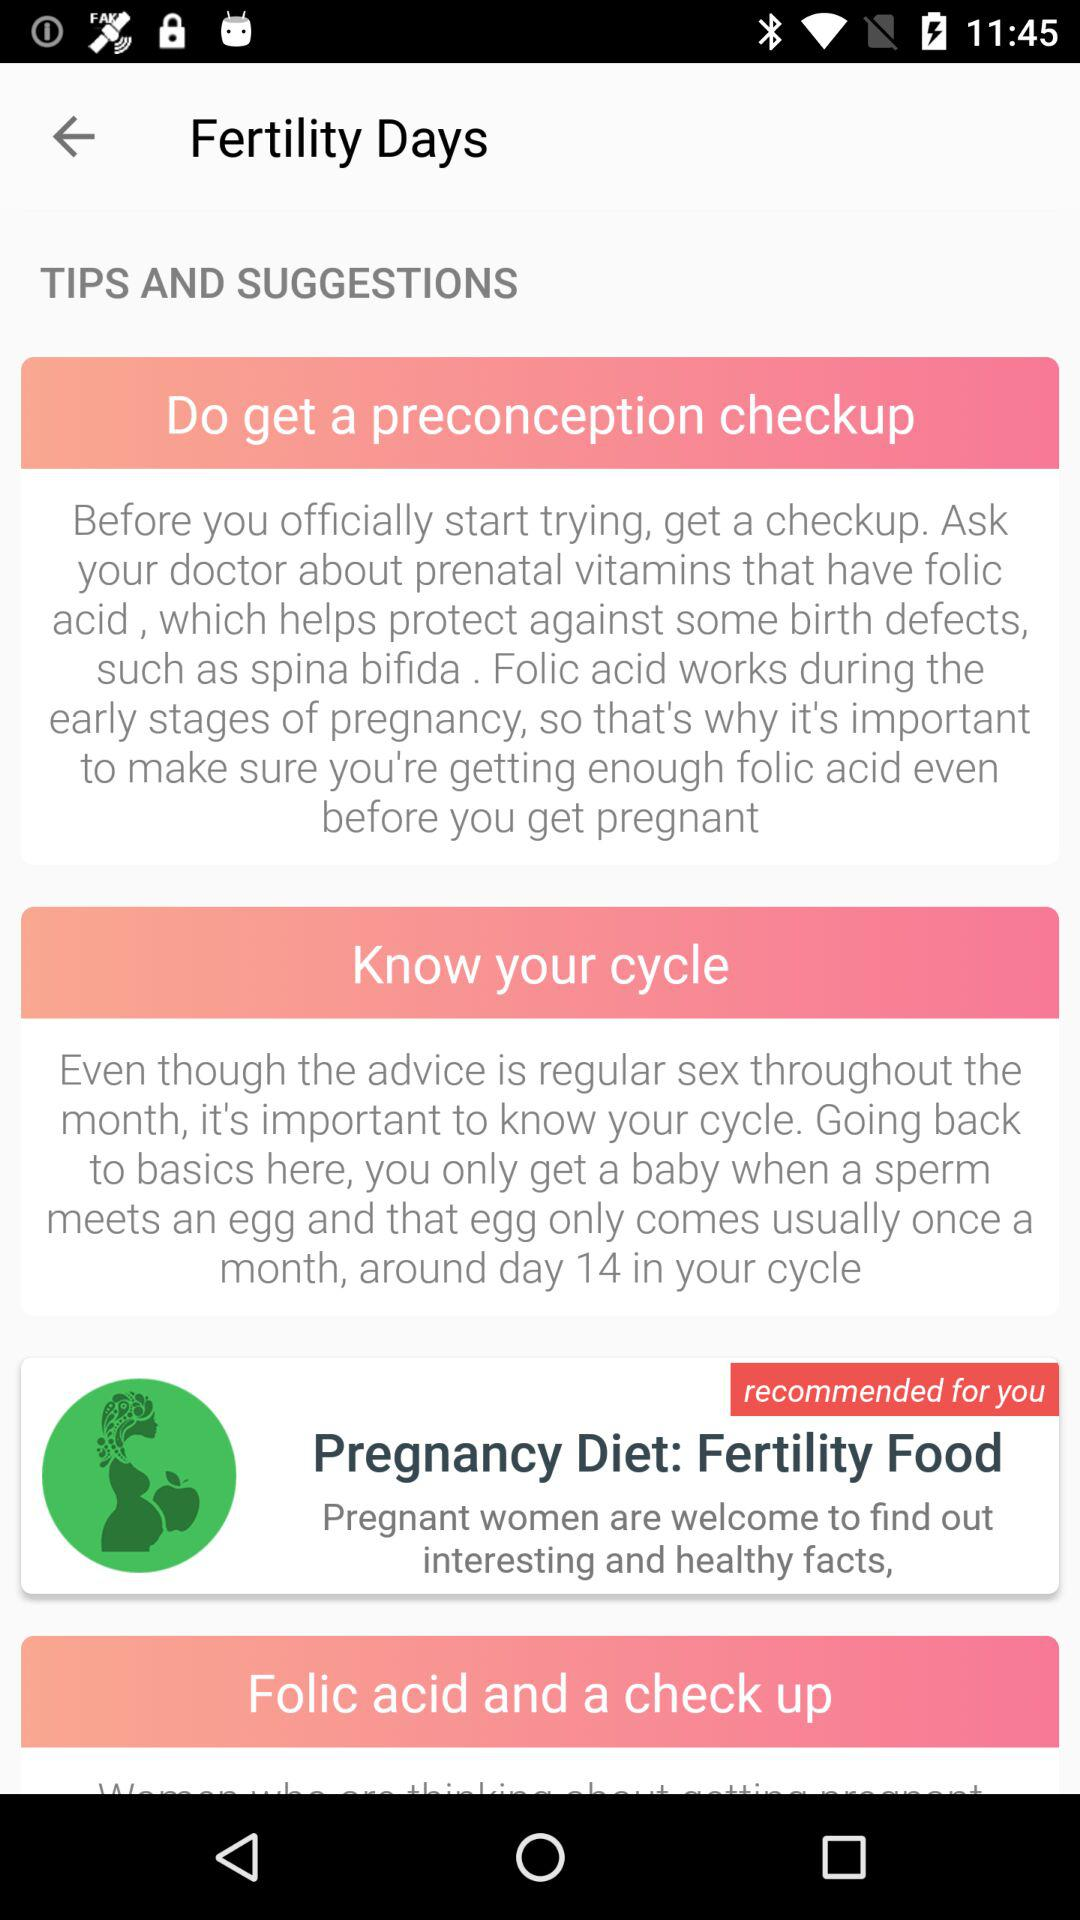How many more tips are there about getting pregnant than about pregnancy diet?
Answer the question using a single word or phrase. 2 